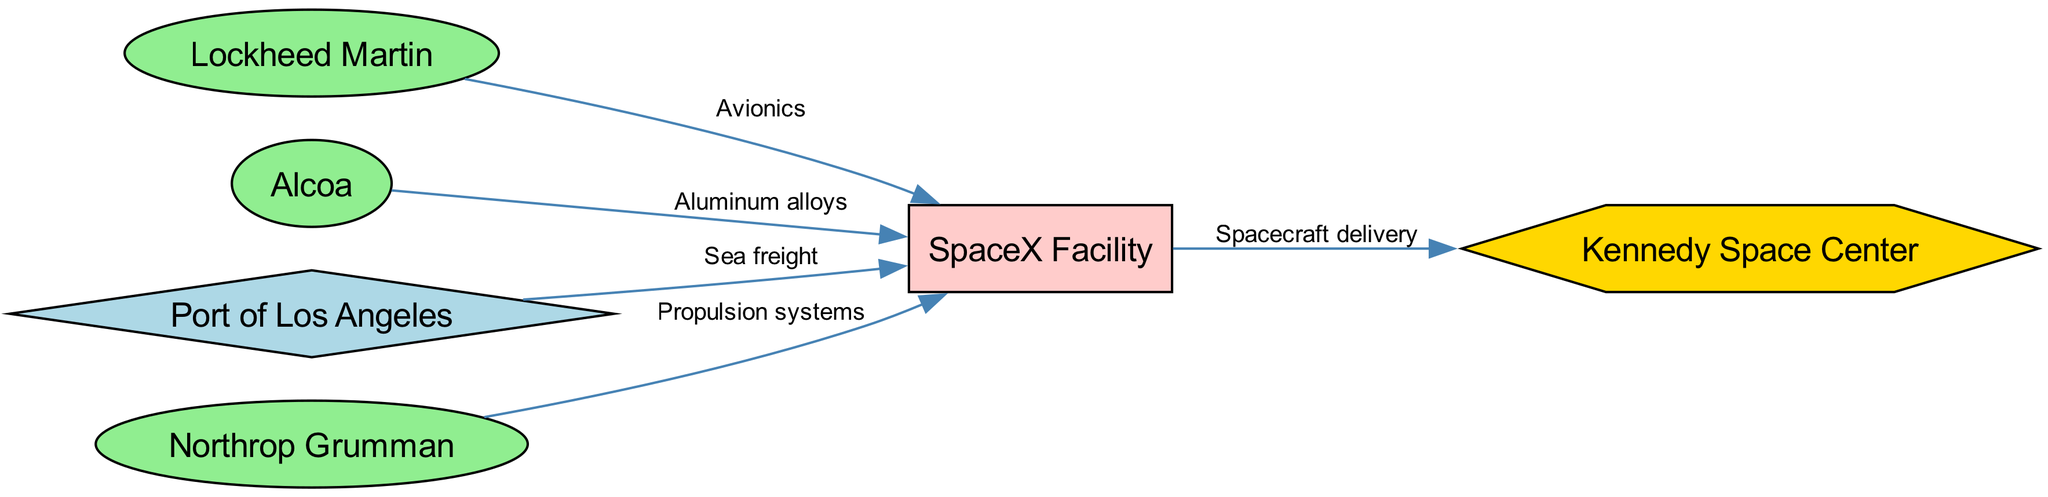What is the total number of nodes in the diagram? The diagram includes 6 defined nodes: SpaceX Facility, Lockheed Martin, Alcoa, Port of Los Angeles, Kennedy Space Center, and Northrop Grumman. Thus, the count of nodes is straightforwardly summed up to 6.
Answer: 6 Which supplier provides propulsion systems? The diagram connects Northrop Grumman as the supplier to the SpaceX Facility for the component labeled propulsion systems. This direct correlation identifies Northrop Grumman as the supplier in question.
Answer: Northrop Grumman How many transportation routes are represented in the diagram? By reviewing the edges originating from the Port of Los Angeles, we identify one transportation route labeled sea freight leading directly to the SpaceX Facility. This shows that there is only one route depicted in the diagram.
Answer: 1 What materials does Lockheed Martin supply? The diagram specifies Lockheed Martin's contribution to the SpaceX Facility, identifying the material provided as avionics. This direct labeling in the edge signifies Lockheed Martin’s specific supply relation.
Answer: Avionics Which facility receives spacecraft delivery? The arrows in the diagram direct from the SpaceX Facility to the Kennedy Space Center, indicating that the spacecraft delivery terminates at the Kennedy Space Center. The edge clarifies the flow between these two nodes.
Answer: Kennedy Space Center Name the transportation hub in the supply chain. The diagram consists of one transportation hub clearly labeled as the Port of Los Angeles. This node is specifically defined with its type and role in the overall supply chain.
Answer: Port of Los Angeles How many suppliers are shown in the diagram? The suppliers listed in the diagram include Lockheed Martin, Alcoa, and Northrop Grumman, making three suppliers in total. This can be simply counted from the defined nodes.
Answer: 3 Which node has the role of production facility? Examining the node types in the diagram, the SpaceX Facility is classified as the production facility, making it the singular production node in this context.
Answer: SpaceX Facility What is the connection between Alcoa and the SpaceX Facility? The edge connecting Alcoa to the SpaceX Facility specifies that Alcoa supplies aluminum alloys to SpaceX, thus establishing this material relationship clearly in the diagram.
Answer: Aluminum alloys 